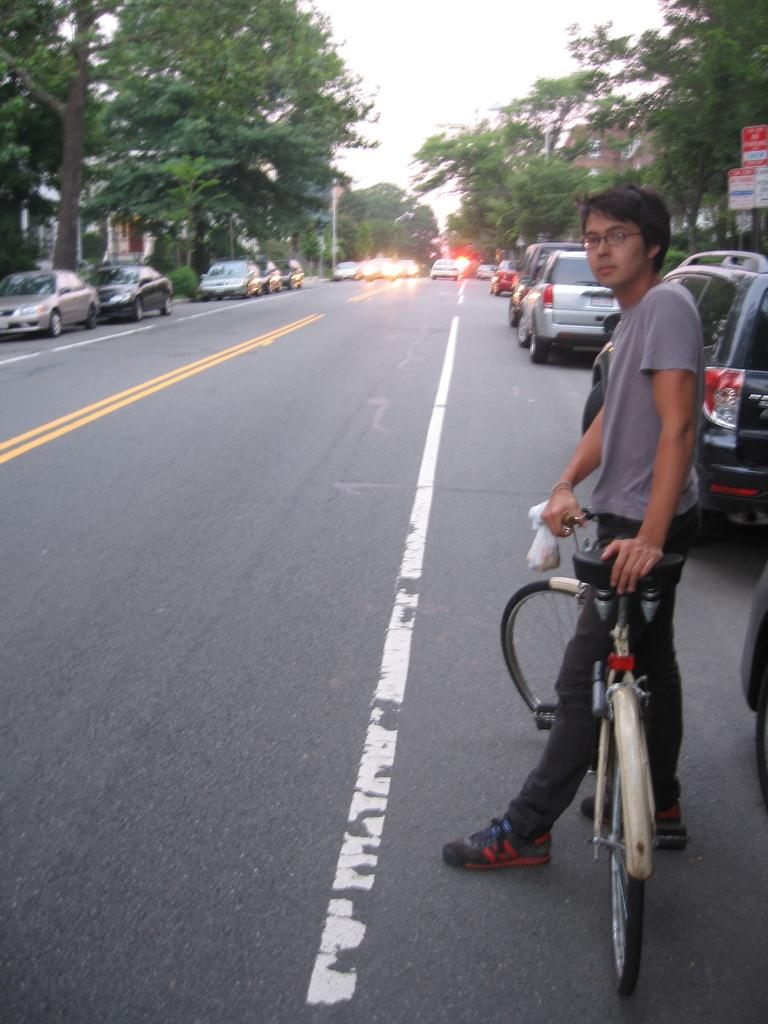Where is the person located in the image? The person is standing on a roadside. What is the person holding in the image? The person is holding a bicycle seat. What can be seen in the background of the image? There is a sky, a tree, and a vehicle visible in the background. What type of suit is the person wearing in the image? There is no suit visible in the image; the person is holding a bicycle seat. Can you see any patches on the person's clothing in the image? There is no information about the person's clothing or patches in the image. Is there any toothpaste visible in the image? There is no toothpaste present in the image. 